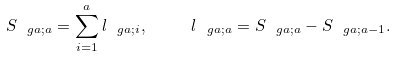<formula> <loc_0><loc_0><loc_500><loc_500>S _ { \ g a ; a } = \sum _ { i = 1 } ^ { a } l _ { \ g a ; i } , \quad \ l _ { \ g a ; a } = S _ { \ g a ; a } - S _ { \ g a ; a - 1 } .</formula> 